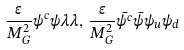<formula> <loc_0><loc_0><loc_500><loc_500>\frac { \epsilon } { M _ { G } ^ { 2 } } \psi ^ { c } \psi \lambda \lambda , \, \frac { \epsilon } { M _ { G } ^ { 2 } } \bar { \psi ^ { c } } \bar { \psi } \psi _ { u } \psi _ { d }</formula> 